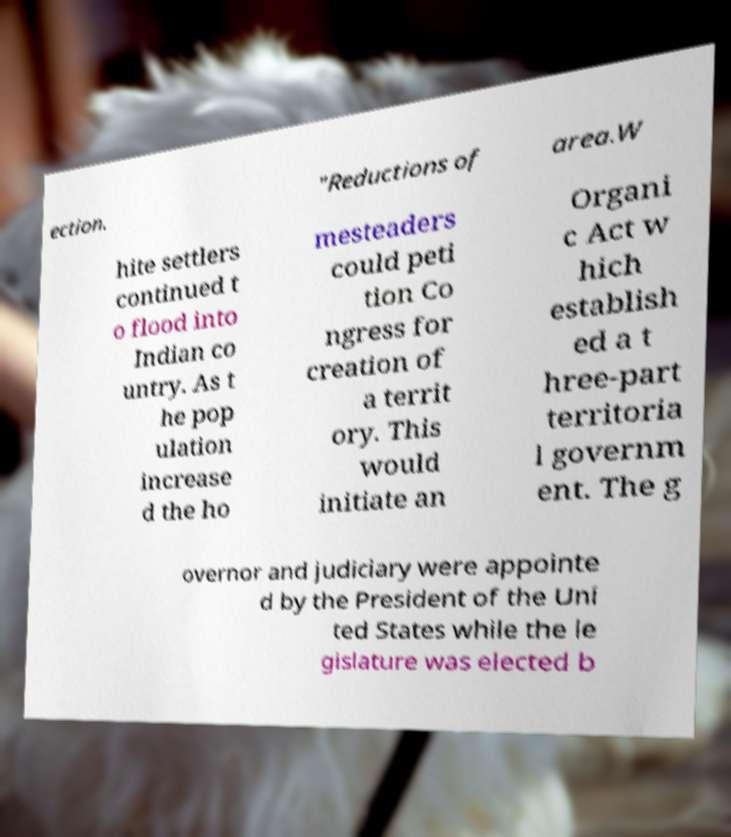Could you extract and type out the text from this image? ection. "Reductions of area.W hite settlers continued t o flood into Indian co untry. As t he pop ulation increase d the ho mesteaders could peti tion Co ngress for creation of a territ ory. This would initiate an Organi c Act w hich establish ed a t hree-part territoria l governm ent. The g overnor and judiciary were appointe d by the President of the Uni ted States while the le gislature was elected b 